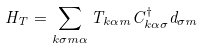Convert formula to latex. <formula><loc_0><loc_0><loc_500><loc_500>H _ { T } = \sum _ { k \sigma m \alpha } T _ { k \alpha m } C ^ { \dagger } _ { k \alpha \sigma } d _ { \sigma m }</formula> 